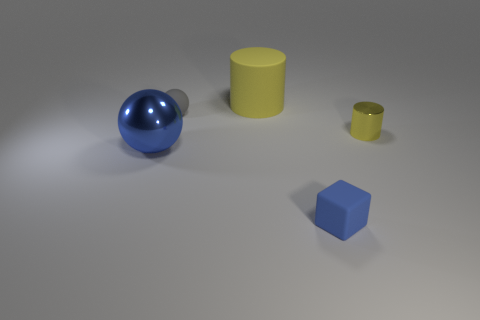Are there more metallic cylinders right of the tiny cylinder than things?
Ensure brevity in your answer.  No. Do the tiny metal object and the metallic thing that is left of the tiny cylinder have the same shape?
Your answer should be compact. No. How many big objects are either red metal cubes or metal spheres?
Ensure brevity in your answer.  1. There is a metal object that is the same color as the large rubber object; what size is it?
Provide a short and direct response. Small. The metallic object in front of the metal thing that is on the right side of the rubber cylinder is what color?
Provide a short and direct response. Blue. Is the small sphere made of the same material as the yellow cylinder right of the large yellow cylinder?
Offer a terse response. No. There is a cylinder that is in front of the big rubber thing; what is it made of?
Make the answer very short. Metal. Are there the same number of large matte things on the right side of the yellow matte cylinder and tiny yellow objects?
Give a very brief answer. No. What material is the cylinder behind the small metal object in front of the yellow matte cylinder made of?
Keep it short and to the point. Rubber. The object that is both on the right side of the large cylinder and left of the tiny shiny cylinder has what shape?
Keep it short and to the point. Cube. 